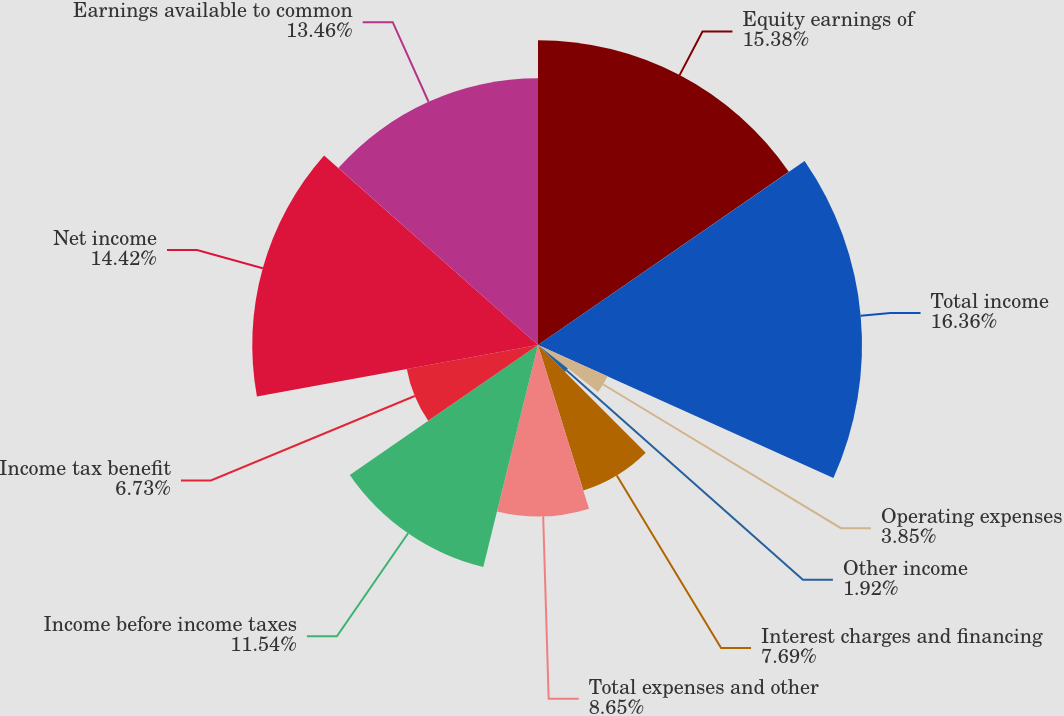<chart> <loc_0><loc_0><loc_500><loc_500><pie_chart><fcel>Equity earnings of<fcel>Total income<fcel>Operating expenses<fcel>Other income<fcel>Interest charges and financing<fcel>Total expenses and other<fcel>Income before income taxes<fcel>Income tax benefit<fcel>Net income<fcel>Earnings available to common<nl><fcel>15.38%<fcel>16.35%<fcel>3.85%<fcel>1.92%<fcel>7.69%<fcel>8.65%<fcel>11.54%<fcel>6.73%<fcel>14.42%<fcel>13.46%<nl></chart> 